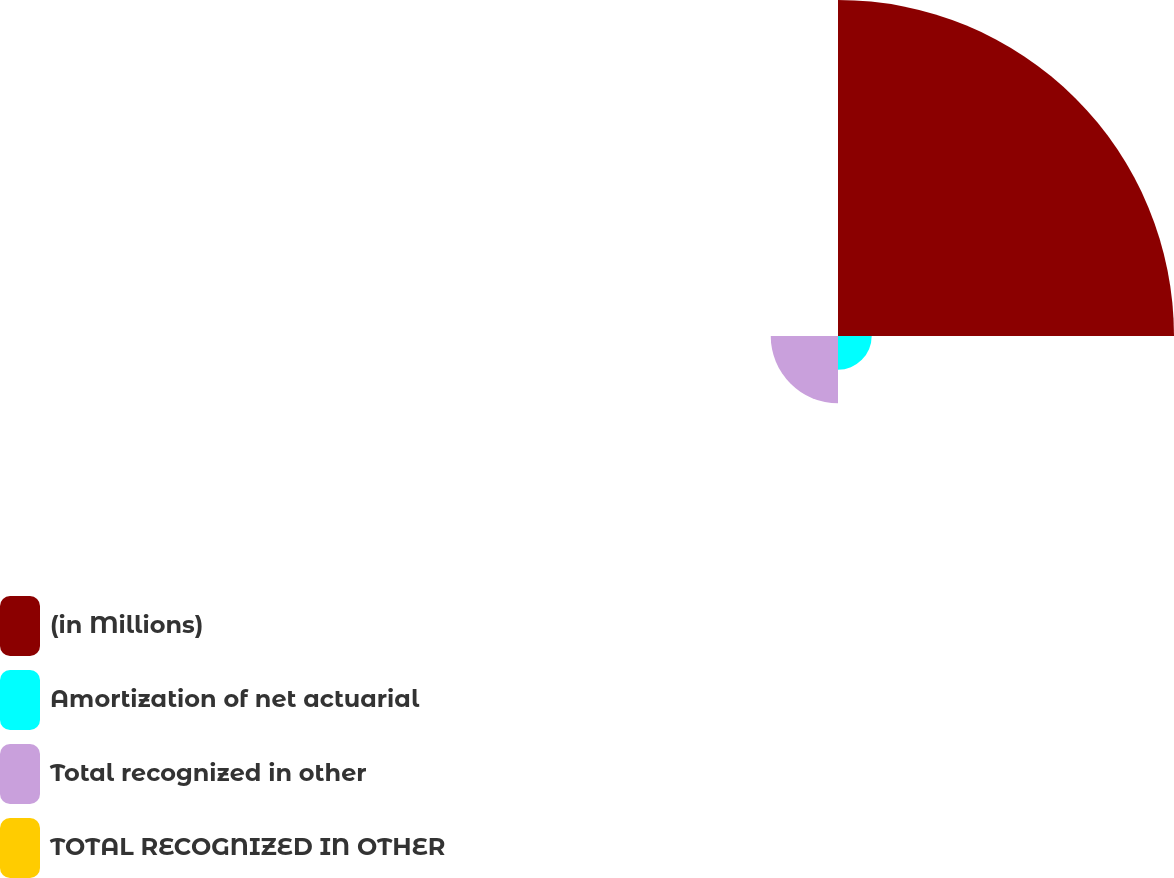<chart> <loc_0><loc_0><loc_500><loc_500><pie_chart><fcel>(in Millions)<fcel>Amortization of net actuarial<fcel>Total recognized in other<fcel>TOTAL RECOGNIZED IN OTHER<nl><fcel>76.88%<fcel>7.71%<fcel>15.39%<fcel>0.02%<nl></chart> 